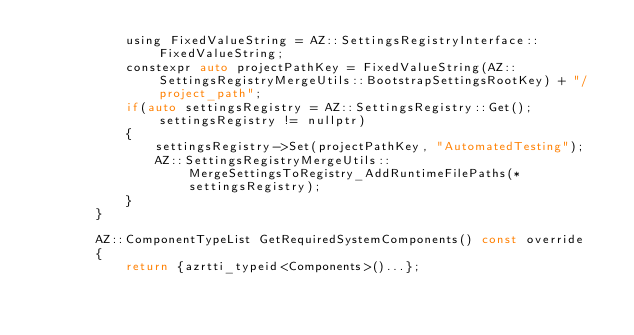<code> <loc_0><loc_0><loc_500><loc_500><_C_>            using FixedValueString = AZ::SettingsRegistryInterface::FixedValueString;
            constexpr auto projectPathKey = FixedValueString(AZ::SettingsRegistryMergeUtils::BootstrapSettingsRootKey) + "/project_path";
            if(auto settingsRegistry = AZ::SettingsRegistry::Get(); settingsRegistry != nullptr)
            {
                settingsRegistry->Set(projectPathKey, "AutomatedTesting");
                AZ::SettingsRegistryMergeUtils::MergeSettingsToRegistry_AddRuntimeFilePaths(*settingsRegistry);
            }
        }

        AZ::ComponentTypeList GetRequiredSystemComponents() const override
        {
            return {azrtti_typeid<Components>()...};</code> 